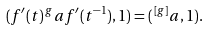Convert formula to latex. <formula><loc_0><loc_0><loc_500><loc_500>( f ^ { \prime } ( t ) \, ^ { g } a f ^ { \prime } ( t ^ { - 1 } ) , 1 ) = ( \, ^ { [ g ] } a , 1 ) .</formula> 